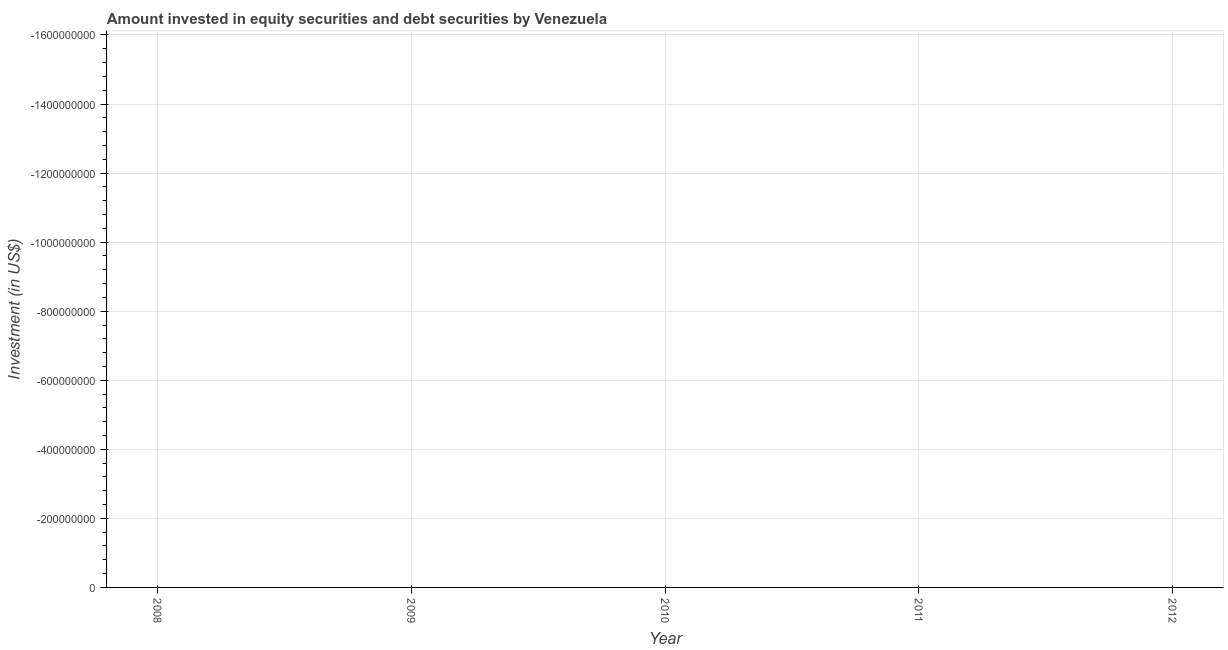What is the portfolio investment in 2012?
Give a very brief answer. 0. What is the median portfolio investment?
Give a very brief answer. 0. In how many years, is the portfolio investment greater than the average portfolio investment taken over all years?
Your answer should be very brief. 0. Does the portfolio investment monotonically increase over the years?
Ensure brevity in your answer.  No. How many years are there in the graph?
Provide a succinct answer. 5. Does the graph contain any zero values?
Provide a succinct answer. Yes. Does the graph contain grids?
Offer a very short reply. Yes. What is the title of the graph?
Ensure brevity in your answer.  Amount invested in equity securities and debt securities by Venezuela. What is the label or title of the X-axis?
Your answer should be very brief. Year. What is the label or title of the Y-axis?
Ensure brevity in your answer.  Investment (in US$). What is the Investment (in US$) of 2009?
Your response must be concise. 0. What is the Investment (in US$) in 2010?
Offer a terse response. 0. 